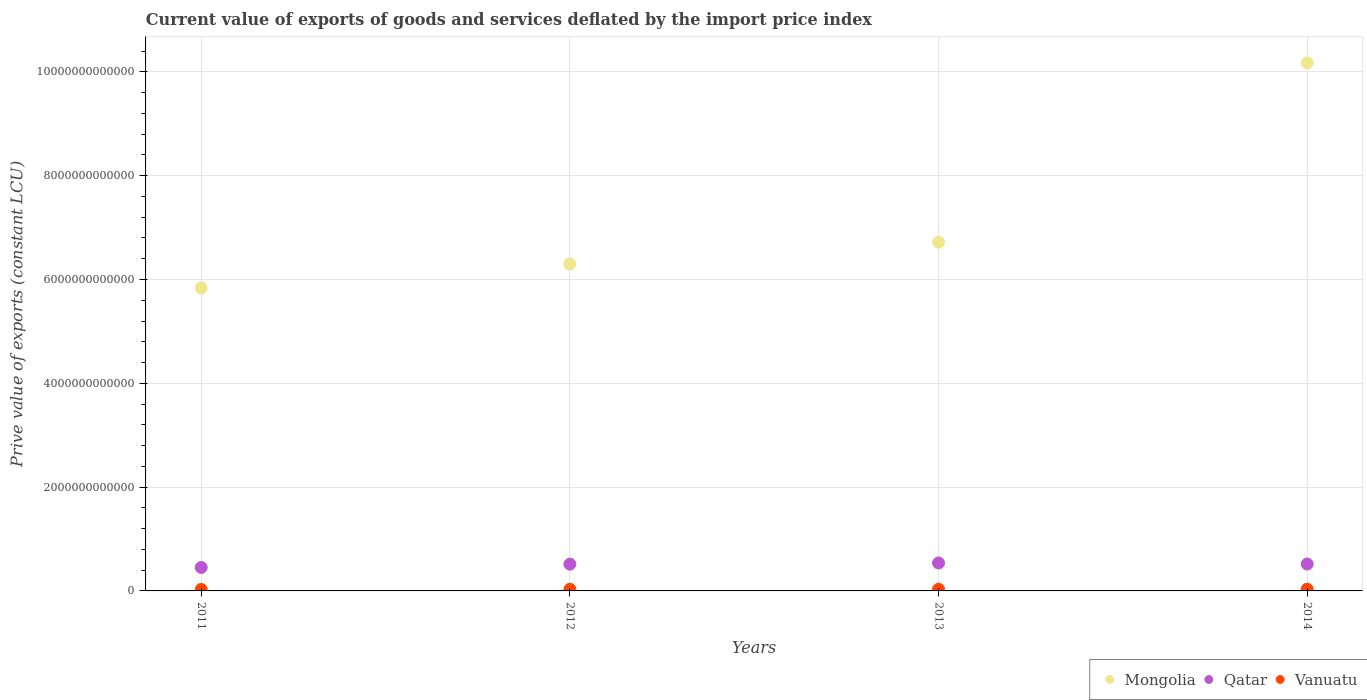What is the prive value of exports in Vanuatu in 2011?
Offer a terse response. 2.90e+1. Across all years, what is the maximum prive value of exports in Mongolia?
Provide a short and direct response. 1.02e+13. Across all years, what is the minimum prive value of exports in Qatar?
Offer a very short reply. 4.52e+11. In which year was the prive value of exports in Vanuatu maximum?
Give a very brief answer. 2014. What is the total prive value of exports in Vanuatu in the graph?
Provide a succinct answer. 1.27e+11. What is the difference between the prive value of exports in Vanuatu in 2011 and that in 2013?
Ensure brevity in your answer.  -3.70e+09. What is the difference between the prive value of exports in Qatar in 2011 and the prive value of exports in Vanuatu in 2013?
Give a very brief answer. 4.19e+11. What is the average prive value of exports in Qatar per year?
Keep it short and to the point. 5.06e+11. In the year 2013, what is the difference between the prive value of exports in Vanuatu and prive value of exports in Mongolia?
Provide a succinct answer. -6.69e+12. What is the ratio of the prive value of exports in Qatar in 2012 to that in 2013?
Offer a terse response. 0.96. Is the prive value of exports in Mongolia in 2012 less than that in 2014?
Provide a succinct answer. Yes. Is the difference between the prive value of exports in Vanuatu in 2013 and 2014 greater than the difference between the prive value of exports in Mongolia in 2013 and 2014?
Ensure brevity in your answer.  Yes. What is the difference between the highest and the second highest prive value of exports in Mongolia?
Your answer should be very brief. 3.45e+12. What is the difference between the highest and the lowest prive value of exports in Mongolia?
Give a very brief answer. 4.34e+12. Is the sum of the prive value of exports in Qatar in 2012 and 2013 greater than the maximum prive value of exports in Mongolia across all years?
Your answer should be very brief. No. Is it the case that in every year, the sum of the prive value of exports in Vanuatu and prive value of exports in Qatar  is greater than the prive value of exports in Mongolia?
Your answer should be very brief. No. Is the prive value of exports in Qatar strictly greater than the prive value of exports in Vanuatu over the years?
Provide a short and direct response. Yes. How many years are there in the graph?
Keep it short and to the point. 4. What is the difference between two consecutive major ticks on the Y-axis?
Keep it short and to the point. 2.00e+12. Are the values on the major ticks of Y-axis written in scientific E-notation?
Your answer should be very brief. No. Does the graph contain any zero values?
Ensure brevity in your answer.  No. Does the graph contain grids?
Provide a succinct answer. Yes. Where does the legend appear in the graph?
Provide a succinct answer. Bottom right. How many legend labels are there?
Your answer should be compact. 3. What is the title of the graph?
Keep it short and to the point. Current value of exports of goods and services deflated by the import price index. Does "Cyprus" appear as one of the legend labels in the graph?
Provide a succinct answer. No. What is the label or title of the Y-axis?
Your answer should be compact. Prive value of exports (constant LCU). What is the Prive value of exports (constant LCU) of Mongolia in 2011?
Offer a terse response. 5.84e+12. What is the Prive value of exports (constant LCU) in Qatar in 2011?
Your response must be concise. 4.52e+11. What is the Prive value of exports (constant LCU) in Vanuatu in 2011?
Your answer should be compact. 2.90e+1. What is the Prive value of exports (constant LCU) of Mongolia in 2012?
Your answer should be very brief. 6.30e+12. What is the Prive value of exports (constant LCU) in Qatar in 2012?
Provide a succinct answer. 5.16e+11. What is the Prive value of exports (constant LCU) of Vanuatu in 2012?
Ensure brevity in your answer.  3.18e+1. What is the Prive value of exports (constant LCU) in Mongolia in 2013?
Offer a terse response. 6.72e+12. What is the Prive value of exports (constant LCU) of Qatar in 2013?
Your answer should be compact. 5.39e+11. What is the Prive value of exports (constant LCU) of Vanuatu in 2013?
Your response must be concise. 3.26e+1. What is the Prive value of exports (constant LCU) of Mongolia in 2014?
Give a very brief answer. 1.02e+13. What is the Prive value of exports (constant LCU) in Qatar in 2014?
Make the answer very short. 5.18e+11. What is the Prive value of exports (constant LCU) in Vanuatu in 2014?
Offer a very short reply. 3.41e+1. Across all years, what is the maximum Prive value of exports (constant LCU) of Mongolia?
Keep it short and to the point. 1.02e+13. Across all years, what is the maximum Prive value of exports (constant LCU) in Qatar?
Give a very brief answer. 5.39e+11. Across all years, what is the maximum Prive value of exports (constant LCU) in Vanuatu?
Ensure brevity in your answer.  3.41e+1. Across all years, what is the minimum Prive value of exports (constant LCU) of Mongolia?
Give a very brief answer. 5.84e+12. Across all years, what is the minimum Prive value of exports (constant LCU) of Qatar?
Offer a very short reply. 4.52e+11. Across all years, what is the minimum Prive value of exports (constant LCU) of Vanuatu?
Your response must be concise. 2.90e+1. What is the total Prive value of exports (constant LCU) in Mongolia in the graph?
Ensure brevity in your answer.  2.90e+13. What is the total Prive value of exports (constant LCU) of Qatar in the graph?
Provide a succinct answer. 2.02e+12. What is the total Prive value of exports (constant LCU) of Vanuatu in the graph?
Provide a succinct answer. 1.27e+11. What is the difference between the Prive value of exports (constant LCU) of Mongolia in 2011 and that in 2012?
Your response must be concise. -4.62e+11. What is the difference between the Prive value of exports (constant LCU) of Qatar in 2011 and that in 2012?
Your answer should be compact. -6.38e+1. What is the difference between the Prive value of exports (constant LCU) of Vanuatu in 2011 and that in 2012?
Offer a very short reply. -2.81e+09. What is the difference between the Prive value of exports (constant LCU) in Mongolia in 2011 and that in 2013?
Make the answer very short. -8.82e+11. What is the difference between the Prive value of exports (constant LCU) of Qatar in 2011 and that in 2013?
Your answer should be very brief. -8.66e+1. What is the difference between the Prive value of exports (constant LCU) of Vanuatu in 2011 and that in 2013?
Offer a terse response. -3.70e+09. What is the difference between the Prive value of exports (constant LCU) of Mongolia in 2011 and that in 2014?
Your answer should be compact. -4.34e+12. What is the difference between the Prive value of exports (constant LCU) in Qatar in 2011 and that in 2014?
Make the answer very short. -6.64e+1. What is the difference between the Prive value of exports (constant LCU) of Vanuatu in 2011 and that in 2014?
Your response must be concise. -5.13e+09. What is the difference between the Prive value of exports (constant LCU) of Mongolia in 2012 and that in 2013?
Ensure brevity in your answer.  -4.20e+11. What is the difference between the Prive value of exports (constant LCU) in Qatar in 2012 and that in 2013?
Ensure brevity in your answer.  -2.28e+1. What is the difference between the Prive value of exports (constant LCU) in Vanuatu in 2012 and that in 2013?
Provide a succinct answer. -8.87e+08. What is the difference between the Prive value of exports (constant LCU) in Mongolia in 2012 and that in 2014?
Provide a short and direct response. -3.87e+12. What is the difference between the Prive value of exports (constant LCU) in Qatar in 2012 and that in 2014?
Offer a very short reply. -2.56e+09. What is the difference between the Prive value of exports (constant LCU) in Vanuatu in 2012 and that in 2014?
Keep it short and to the point. -2.32e+09. What is the difference between the Prive value of exports (constant LCU) in Mongolia in 2013 and that in 2014?
Your response must be concise. -3.45e+12. What is the difference between the Prive value of exports (constant LCU) of Qatar in 2013 and that in 2014?
Your answer should be compact. 2.02e+1. What is the difference between the Prive value of exports (constant LCU) in Vanuatu in 2013 and that in 2014?
Provide a succinct answer. -1.43e+09. What is the difference between the Prive value of exports (constant LCU) of Mongolia in 2011 and the Prive value of exports (constant LCU) of Qatar in 2012?
Offer a terse response. 5.32e+12. What is the difference between the Prive value of exports (constant LCU) in Mongolia in 2011 and the Prive value of exports (constant LCU) in Vanuatu in 2012?
Keep it short and to the point. 5.81e+12. What is the difference between the Prive value of exports (constant LCU) in Qatar in 2011 and the Prive value of exports (constant LCU) in Vanuatu in 2012?
Give a very brief answer. 4.20e+11. What is the difference between the Prive value of exports (constant LCU) in Mongolia in 2011 and the Prive value of exports (constant LCU) in Qatar in 2013?
Give a very brief answer. 5.30e+12. What is the difference between the Prive value of exports (constant LCU) in Mongolia in 2011 and the Prive value of exports (constant LCU) in Vanuatu in 2013?
Keep it short and to the point. 5.80e+12. What is the difference between the Prive value of exports (constant LCU) of Qatar in 2011 and the Prive value of exports (constant LCU) of Vanuatu in 2013?
Ensure brevity in your answer.  4.19e+11. What is the difference between the Prive value of exports (constant LCU) in Mongolia in 2011 and the Prive value of exports (constant LCU) in Qatar in 2014?
Your answer should be very brief. 5.32e+12. What is the difference between the Prive value of exports (constant LCU) of Mongolia in 2011 and the Prive value of exports (constant LCU) of Vanuatu in 2014?
Keep it short and to the point. 5.80e+12. What is the difference between the Prive value of exports (constant LCU) in Qatar in 2011 and the Prive value of exports (constant LCU) in Vanuatu in 2014?
Give a very brief answer. 4.18e+11. What is the difference between the Prive value of exports (constant LCU) in Mongolia in 2012 and the Prive value of exports (constant LCU) in Qatar in 2013?
Offer a very short reply. 5.76e+12. What is the difference between the Prive value of exports (constant LCU) of Mongolia in 2012 and the Prive value of exports (constant LCU) of Vanuatu in 2013?
Keep it short and to the point. 6.27e+12. What is the difference between the Prive value of exports (constant LCU) in Qatar in 2012 and the Prive value of exports (constant LCU) in Vanuatu in 2013?
Offer a terse response. 4.83e+11. What is the difference between the Prive value of exports (constant LCU) in Mongolia in 2012 and the Prive value of exports (constant LCU) in Qatar in 2014?
Ensure brevity in your answer.  5.78e+12. What is the difference between the Prive value of exports (constant LCU) in Mongolia in 2012 and the Prive value of exports (constant LCU) in Vanuatu in 2014?
Your answer should be compact. 6.26e+12. What is the difference between the Prive value of exports (constant LCU) in Qatar in 2012 and the Prive value of exports (constant LCU) in Vanuatu in 2014?
Your answer should be very brief. 4.82e+11. What is the difference between the Prive value of exports (constant LCU) of Mongolia in 2013 and the Prive value of exports (constant LCU) of Qatar in 2014?
Ensure brevity in your answer.  6.20e+12. What is the difference between the Prive value of exports (constant LCU) of Mongolia in 2013 and the Prive value of exports (constant LCU) of Vanuatu in 2014?
Make the answer very short. 6.69e+12. What is the difference between the Prive value of exports (constant LCU) in Qatar in 2013 and the Prive value of exports (constant LCU) in Vanuatu in 2014?
Keep it short and to the point. 5.04e+11. What is the average Prive value of exports (constant LCU) in Mongolia per year?
Give a very brief answer. 7.26e+12. What is the average Prive value of exports (constant LCU) in Qatar per year?
Provide a succinct answer. 5.06e+11. What is the average Prive value of exports (constant LCU) of Vanuatu per year?
Your response must be concise. 3.19e+1. In the year 2011, what is the difference between the Prive value of exports (constant LCU) of Mongolia and Prive value of exports (constant LCU) of Qatar?
Keep it short and to the point. 5.38e+12. In the year 2011, what is the difference between the Prive value of exports (constant LCU) of Mongolia and Prive value of exports (constant LCU) of Vanuatu?
Your answer should be compact. 5.81e+12. In the year 2011, what is the difference between the Prive value of exports (constant LCU) in Qatar and Prive value of exports (constant LCU) in Vanuatu?
Make the answer very short. 4.23e+11. In the year 2012, what is the difference between the Prive value of exports (constant LCU) in Mongolia and Prive value of exports (constant LCU) in Qatar?
Offer a terse response. 5.78e+12. In the year 2012, what is the difference between the Prive value of exports (constant LCU) in Mongolia and Prive value of exports (constant LCU) in Vanuatu?
Offer a very short reply. 6.27e+12. In the year 2012, what is the difference between the Prive value of exports (constant LCU) in Qatar and Prive value of exports (constant LCU) in Vanuatu?
Keep it short and to the point. 4.84e+11. In the year 2013, what is the difference between the Prive value of exports (constant LCU) of Mongolia and Prive value of exports (constant LCU) of Qatar?
Your response must be concise. 6.18e+12. In the year 2013, what is the difference between the Prive value of exports (constant LCU) in Mongolia and Prive value of exports (constant LCU) in Vanuatu?
Keep it short and to the point. 6.69e+12. In the year 2013, what is the difference between the Prive value of exports (constant LCU) of Qatar and Prive value of exports (constant LCU) of Vanuatu?
Give a very brief answer. 5.06e+11. In the year 2014, what is the difference between the Prive value of exports (constant LCU) in Mongolia and Prive value of exports (constant LCU) in Qatar?
Provide a succinct answer. 9.65e+12. In the year 2014, what is the difference between the Prive value of exports (constant LCU) in Mongolia and Prive value of exports (constant LCU) in Vanuatu?
Your answer should be very brief. 1.01e+13. In the year 2014, what is the difference between the Prive value of exports (constant LCU) of Qatar and Prive value of exports (constant LCU) of Vanuatu?
Your answer should be compact. 4.84e+11. What is the ratio of the Prive value of exports (constant LCU) in Mongolia in 2011 to that in 2012?
Offer a very short reply. 0.93. What is the ratio of the Prive value of exports (constant LCU) of Qatar in 2011 to that in 2012?
Offer a terse response. 0.88. What is the ratio of the Prive value of exports (constant LCU) of Vanuatu in 2011 to that in 2012?
Ensure brevity in your answer.  0.91. What is the ratio of the Prive value of exports (constant LCU) of Mongolia in 2011 to that in 2013?
Ensure brevity in your answer.  0.87. What is the ratio of the Prive value of exports (constant LCU) in Qatar in 2011 to that in 2013?
Provide a succinct answer. 0.84. What is the ratio of the Prive value of exports (constant LCU) of Vanuatu in 2011 to that in 2013?
Offer a terse response. 0.89. What is the ratio of the Prive value of exports (constant LCU) of Mongolia in 2011 to that in 2014?
Keep it short and to the point. 0.57. What is the ratio of the Prive value of exports (constant LCU) of Qatar in 2011 to that in 2014?
Keep it short and to the point. 0.87. What is the ratio of the Prive value of exports (constant LCU) of Vanuatu in 2011 to that in 2014?
Your answer should be compact. 0.85. What is the ratio of the Prive value of exports (constant LCU) in Mongolia in 2012 to that in 2013?
Your answer should be very brief. 0.94. What is the ratio of the Prive value of exports (constant LCU) in Qatar in 2012 to that in 2013?
Your answer should be compact. 0.96. What is the ratio of the Prive value of exports (constant LCU) of Vanuatu in 2012 to that in 2013?
Give a very brief answer. 0.97. What is the ratio of the Prive value of exports (constant LCU) of Mongolia in 2012 to that in 2014?
Your answer should be very brief. 0.62. What is the ratio of the Prive value of exports (constant LCU) of Qatar in 2012 to that in 2014?
Your response must be concise. 1. What is the ratio of the Prive value of exports (constant LCU) in Vanuatu in 2012 to that in 2014?
Make the answer very short. 0.93. What is the ratio of the Prive value of exports (constant LCU) in Mongolia in 2013 to that in 2014?
Offer a very short reply. 0.66. What is the ratio of the Prive value of exports (constant LCU) of Qatar in 2013 to that in 2014?
Your answer should be very brief. 1.04. What is the ratio of the Prive value of exports (constant LCU) in Vanuatu in 2013 to that in 2014?
Ensure brevity in your answer.  0.96. What is the difference between the highest and the second highest Prive value of exports (constant LCU) in Mongolia?
Keep it short and to the point. 3.45e+12. What is the difference between the highest and the second highest Prive value of exports (constant LCU) in Qatar?
Make the answer very short. 2.02e+1. What is the difference between the highest and the second highest Prive value of exports (constant LCU) in Vanuatu?
Ensure brevity in your answer.  1.43e+09. What is the difference between the highest and the lowest Prive value of exports (constant LCU) of Mongolia?
Make the answer very short. 4.34e+12. What is the difference between the highest and the lowest Prive value of exports (constant LCU) of Qatar?
Offer a terse response. 8.66e+1. What is the difference between the highest and the lowest Prive value of exports (constant LCU) in Vanuatu?
Ensure brevity in your answer.  5.13e+09. 